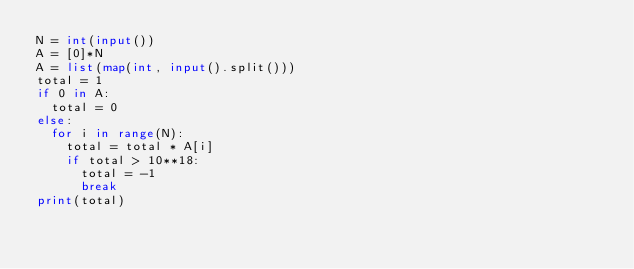<code> <loc_0><loc_0><loc_500><loc_500><_Python_>N = int(input())
A = [0]*N
A = list(map(int, input().split()))
total = 1
if 0 in A:
  total = 0
else:
  for i in range(N):
    total = total * A[i]
    if total > 10**18:
      total = -1
      break
print(total)</code> 